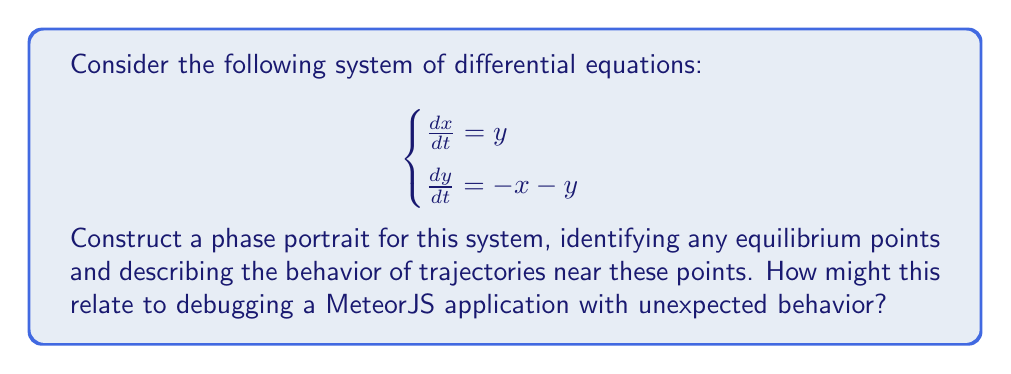Give your solution to this math problem. To construct the phase portrait, we'll follow these steps:

1. Find equilibrium points:
   Set $\frac{dx}{dt} = 0$ and $\frac{dy}{dt} = 0$:
   $$\begin{cases}
   y = 0 \\
   -x - y = 0
   \end{cases}$$
   Solving this, we get $(x, y) = (0, 0)$. There is only one equilibrium point at the origin.

2. Analyze the behavior near the equilibrium point:
   Calculate the Jacobian matrix at $(0, 0)$:
   $$J = \begin{bmatrix}
   \frac{\partial}{\partial x}(y) & \frac{\partial}{\partial y}(y) \\
   \frac{\partial}{\partial x}(-x-y) & \frac{\partial}{\partial y}(-x-y)
   \end{bmatrix} = \begin{bmatrix}
   0 & 1 \\
   -1 & -1
   \end{bmatrix}$$

   Find eigenvalues:
   $$\det(J - \lambda I) = \begin{vmatrix}
   -\lambda & 1 \\
   -1 & -1-\lambda
   \end{vmatrix} = \lambda^2 + \lambda + 1 = 0$$
   
   Solving this, we get $\lambda = -\frac{1}{2} \pm i\frac{\sqrt{3}}{2}$

   The eigenvalues have negative real parts and non-zero imaginary parts, indicating a stable spiral point.

3. Sketch the phase portrait:
   - Draw arrows pointing inward towards the origin in a spiral pattern.
   - Trajectories will circle around the origin while approaching it.

4. Relation to MeteorJS debugging:
   This system's behavior is analogous to debugging a MeteorJS application with unexpected behavior. The spiral pattern represents the iterative process of identifying and fixing issues. As you make progress (moving closer to the origin), the magnitude of the problems decreases, but you may need to circle around the solution a few times before reaching it.

[asy]
import graph;
size(200);
real f(real x, real y) { return y; }
real g(real x, real y) { return -x - y; }
add(vectorfield(f, g, (-3,-3), (3,3), 0.5));
dot((0,0));
label("(0,0)", (0,0), SE);
[/asy]
Answer: Stable spiral point at (0,0); trajectories spiral inward. 